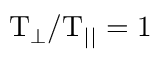<formula> <loc_0><loc_0><loc_500><loc_500>T _ { \perp } / T _ { | | } = 1</formula> 